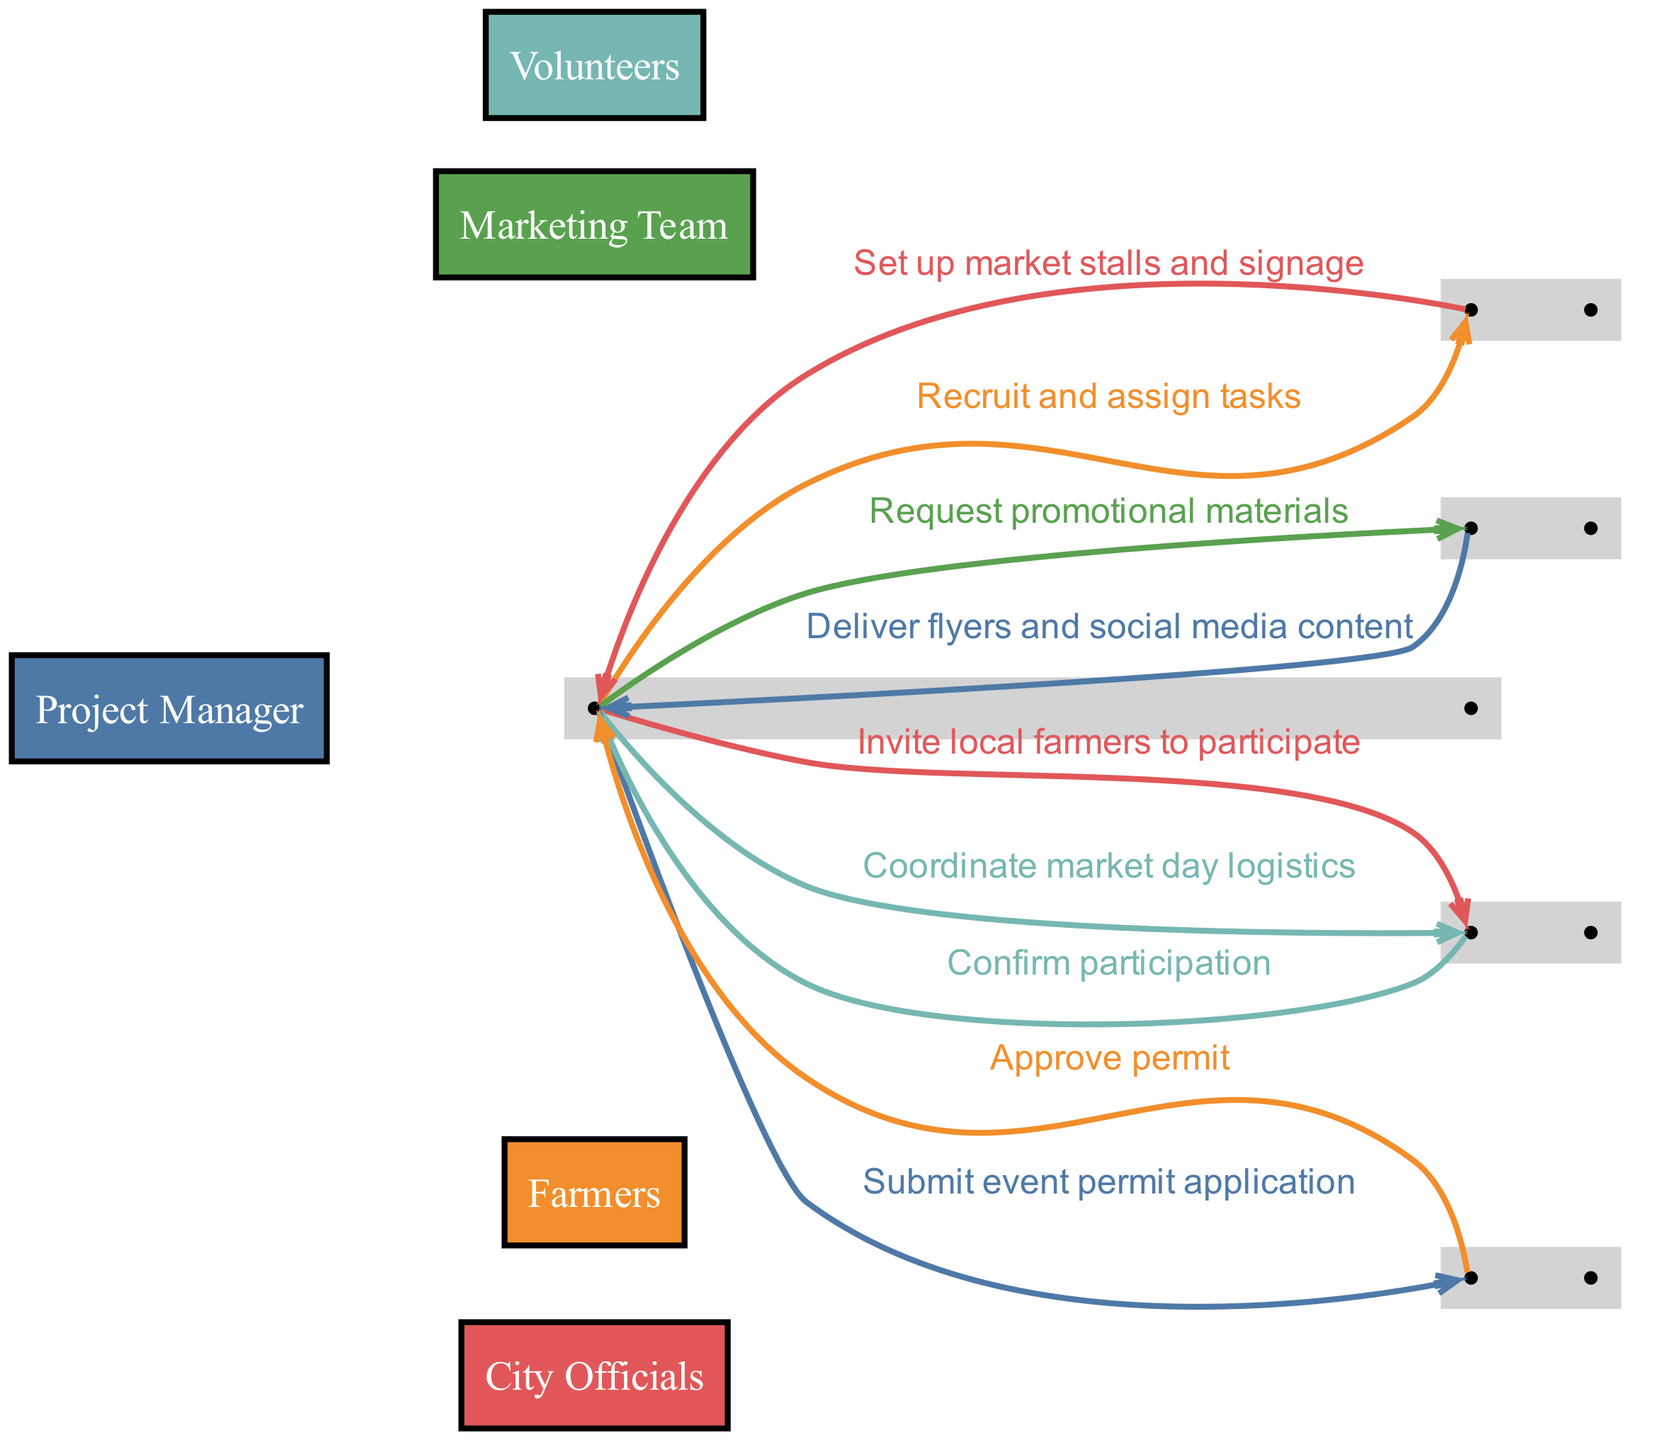What is the first action in the sequence? The first action in the sequence is initiated by the Project Manager submitting the event permit application to the City Officials.
Answer: Submit event permit application How many actors are involved in the process? There are five distinct actors involved in the process: Project Manager, Farmers, City Officials, Volunteers, and Marketing Team.
Answer: Five Who delivers the promotional materials? The Marketing Team is responsible for delivering the promotional materials such as flyers and social media content to the Project Manager.
Answer: Marketing Team What is the last action performed in the sequence? The last action performed is the Project Manager coordinating market day logistics with the Farmers.
Answer: Coordinate market day logistics Which actor confirms participation after being invited? The Farmers confirm their participation after being invited by the Project Manager to take part in the event.
Answer: Farmers What action follows the approval of the event permit? After the City Officials approve the permit, the Project Manager invites local farmers to participate in the farmers' market event.
Answer: Invite local farmers to participate How many actions are taken by the Project Manager? The Project Manager takes four actions throughout the sequence: submitting the event permit application, inviting local farmers, requesting promotional materials, and coordinating market day logistics.
Answer: Four Which actor is involved in setting up market stalls? The Volunteers are the actors responsible for setting up market stalls and signage based on the tasks assigned by the Project Manager.
Answer: Volunteers What color represents the Marketing Team in the diagram? The Marketing Team is represented by a specific color in the diagram; based on the color assignment, it corresponds to the fourth color listed, which is '#76B7B2'.
Answer: '#76B7B2' 